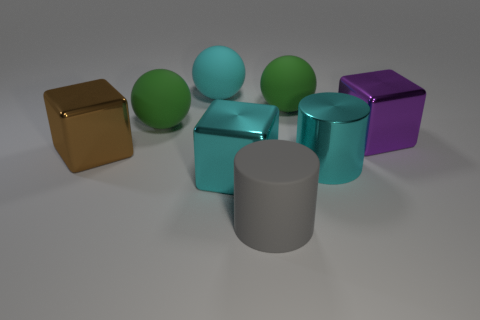Do the big cube behind the brown cube and the large brown object have the same material?
Offer a very short reply. Yes. How many large rubber objects are to the right of the cyan rubber thing and behind the purple cube?
Provide a succinct answer. 1. Are there more large green spheres than large rubber balls?
Your response must be concise. No. There is a big matte ball to the right of the cyan block; is its color the same as the rubber sphere on the left side of the large cyan rubber thing?
Provide a succinct answer. Yes. Are there any big cyan blocks in front of the big block right of the cyan block?
Your response must be concise. Yes. Are there fewer large rubber cylinders that are behind the large rubber cylinder than metallic objects behind the brown shiny cube?
Give a very brief answer. Yes. Is the material of the cube right of the gray rubber cylinder the same as the green ball left of the big gray cylinder?
Your answer should be very brief. No. What number of tiny objects are cyan metallic cubes or green rubber balls?
Ensure brevity in your answer.  0. There is a brown thing that is the same material as the big purple object; what shape is it?
Ensure brevity in your answer.  Cube. Are there fewer gray matte cylinders that are right of the cyan shiny cylinder than large purple rubber blocks?
Provide a succinct answer. No. 